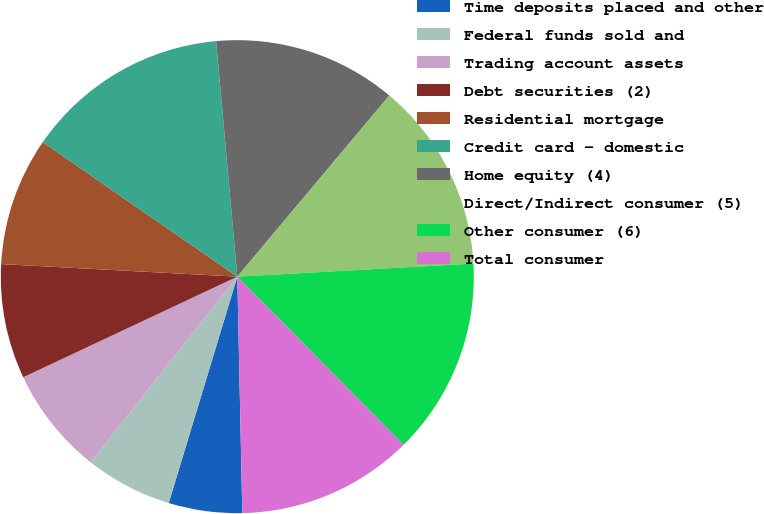Convert chart. <chart><loc_0><loc_0><loc_500><loc_500><pie_chart><fcel>Time deposits placed and other<fcel>Federal funds sold and<fcel>Trading account assets<fcel>Debt securities (2)<fcel>Residential mortgage<fcel>Credit card - domestic<fcel>Home equity (4)<fcel>Direct/Indirect consumer (5)<fcel>Other consumer (6)<fcel>Total consumer<nl><fcel>5.02%<fcel>5.96%<fcel>7.37%<fcel>7.84%<fcel>8.78%<fcel>13.95%<fcel>12.54%<fcel>13.01%<fcel>13.48%<fcel>12.07%<nl></chart> 